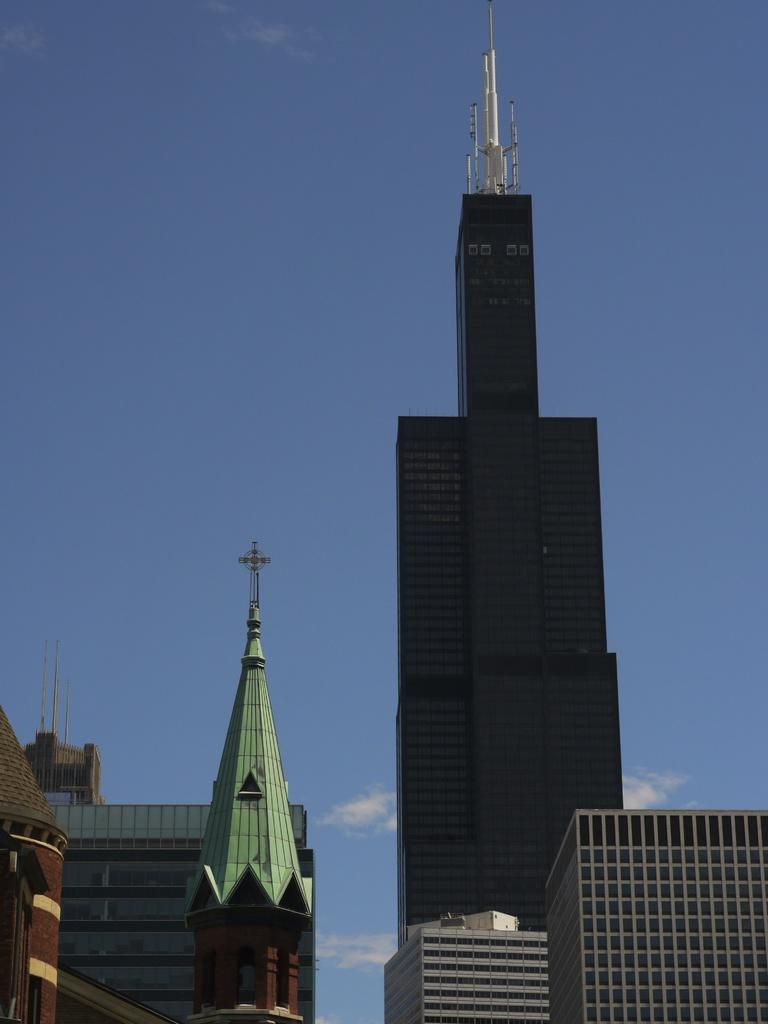What type of structures can be seen in the image? There are many buildings in the image. Can you describe any specific features of these buildings? Yes, there is a tower on top of one of the buildings and a cross on top of another building. What is visible in the background of the image? Sky is visible in the background of the image. What can be observed in the sky? Clouds are present in the sky. What type of cabbage is being used to hold up the tower in the image? There is no cabbage present in the image, and it is not being used to hold up the tower. How does the slip affect the stability of the cross on top of the building in the image? There is no mention of a slip in the image, and it does not affect the stability of the cross on top of the building. 